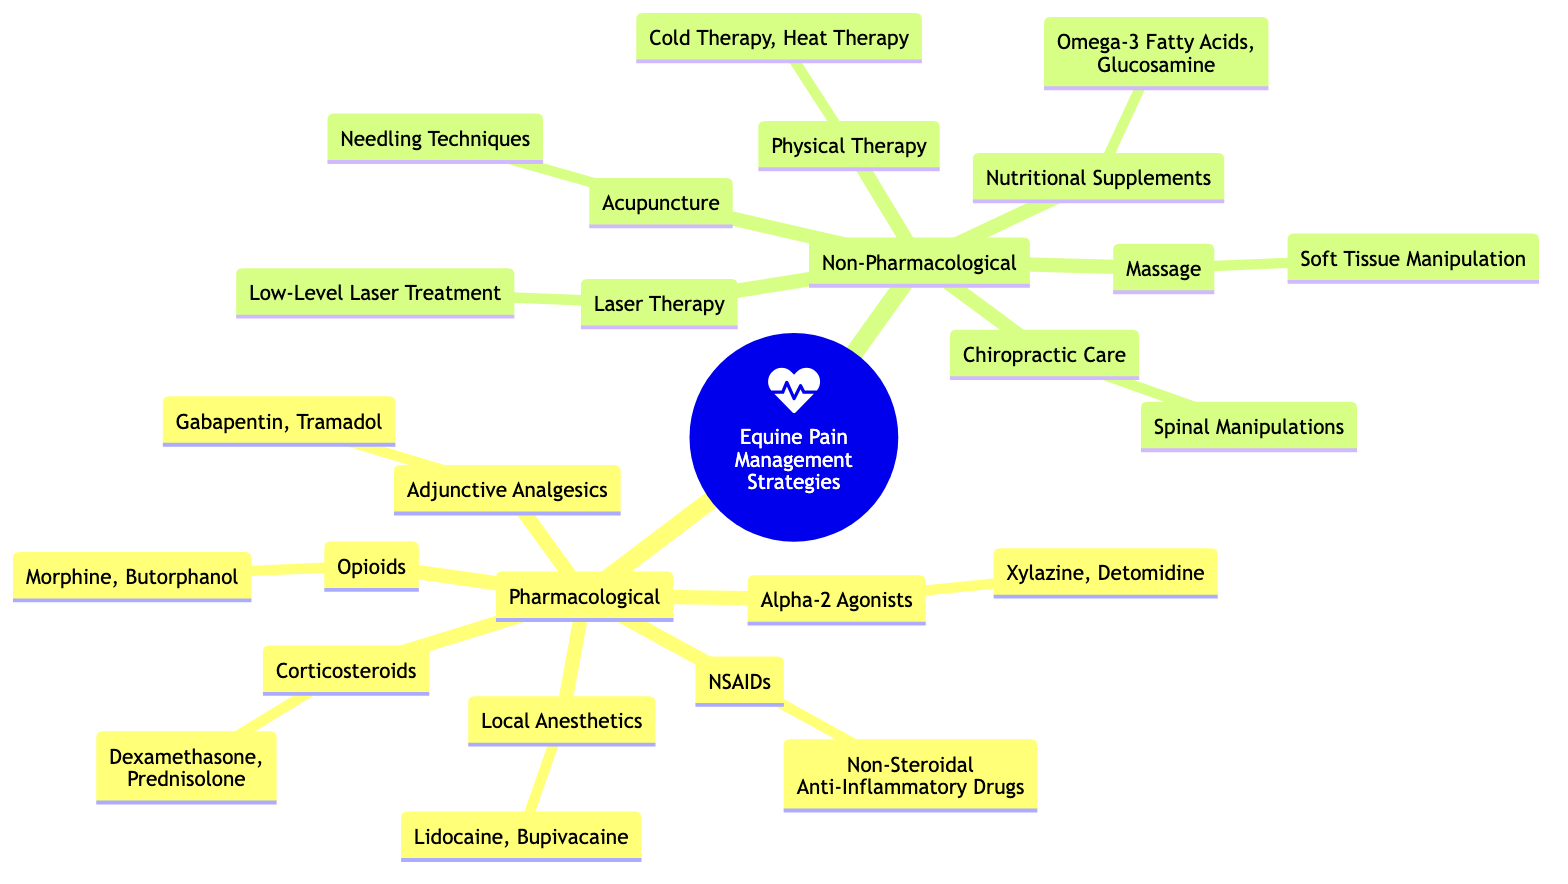What are the two main categories of pain management strategies? The diagram distinguishes pain management strategies into two primary categories: Pharmacological and Non-Pharmacological. This is evident from the root node branching into these two main sections.
Answer: Pharmacological, Non-Pharmacological How many types of pharmacological strategies are listed? The pharmacological section includes six distinct types: NSAIDs, Opioids, Local Anesthetics, Alpha-2 Agonists, Corticosteroids, and Adjunctive Analgesics. Counting these types gives a total of six.
Answer: 6 What are the names of two local anesthetics mentioned? The local anesthetics listed in the diagram are Lidocaine and Bupivacaine. These two names are specifically listed under the Local Anesthetics node.
Answer: Lidocaine, Bupivacaine Which non-pharmacological strategy involves using needling techniques? The acupuncture strategy within the non-pharmacological section is specifically associated with needling techniques. This can be directly noted in the diagram's description of acupuncture.
Answer: Acupuncture How many adjunctive analgesics are mentioned? The diagram lists two adjunctive analgesics: Gabapentin and Tramadol. Both are clearly outlined in the Adjunctive Analgesics node.
Answer: 2 Which opioid is specifically listed in the diagram? Morphine is the specific opioid mentioned under the Opioids node in the pharmacological section. It is one of the two opioids identified in the diagram.
Answer: Morphine What type of therapy is used for soft tissue manipulation? The type of therapy identified for soft tissue manipulation in the non-pharmacological strategies is Massage, which is explicitly described in the diagram.
Answer: Massage What is one nutritional supplement mentioned for pain management? Omega-3 Fatty Acids is one of the nutritional supplements identified in the non-pharmacological section. The diagram lists supplements to aid in pain management.
Answer: Omega-3 Fatty Acids 